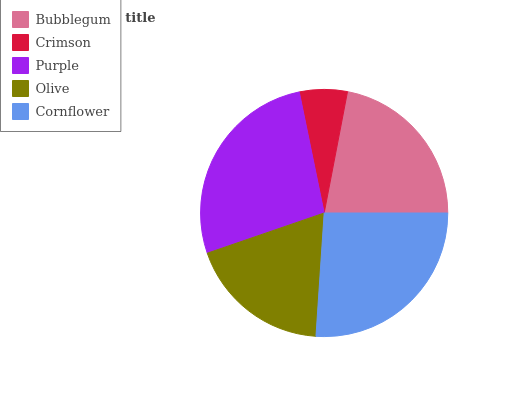Is Crimson the minimum?
Answer yes or no. Yes. Is Purple the maximum?
Answer yes or no. Yes. Is Purple the minimum?
Answer yes or no. No. Is Crimson the maximum?
Answer yes or no. No. Is Purple greater than Crimson?
Answer yes or no. Yes. Is Crimson less than Purple?
Answer yes or no. Yes. Is Crimson greater than Purple?
Answer yes or no. No. Is Purple less than Crimson?
Answer yes or no. No. Is Bubblegum the high median?
Answer yes or no. Yes. Is Bubblegum the low median?
Answer yes or no. Yes. Is Olive the high median?
Answer yes or no. No. Is Olive the low median?
Answer yes or no. No. 